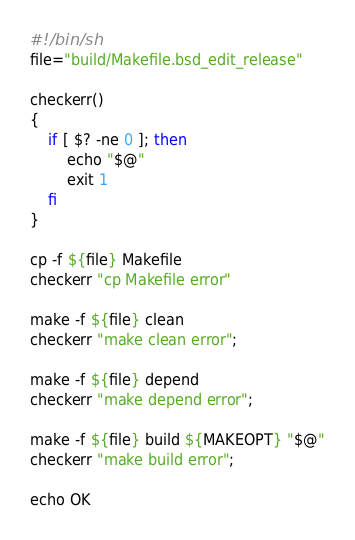Convert code to text. <code><loc_0><loc_0><loc_500><loc_500><_Bash_>#!/bin/sh
file="build/Makefile.bsd_edit_release"

checkerr()
{
	if [ $? -ne 0 ]; then
		echo "$@"
		exit 1
	fi
}

cp -f ${file} Makefile
checkerr "cp Makefile error"

make -f ${file} clean
checkerr "make clean error";

make -f ${file} depend
checkerr "make depend error";

make -f ${file} build ${MAKEOPT} "$@"
checkerr "make build error";

echo OK

</code> 